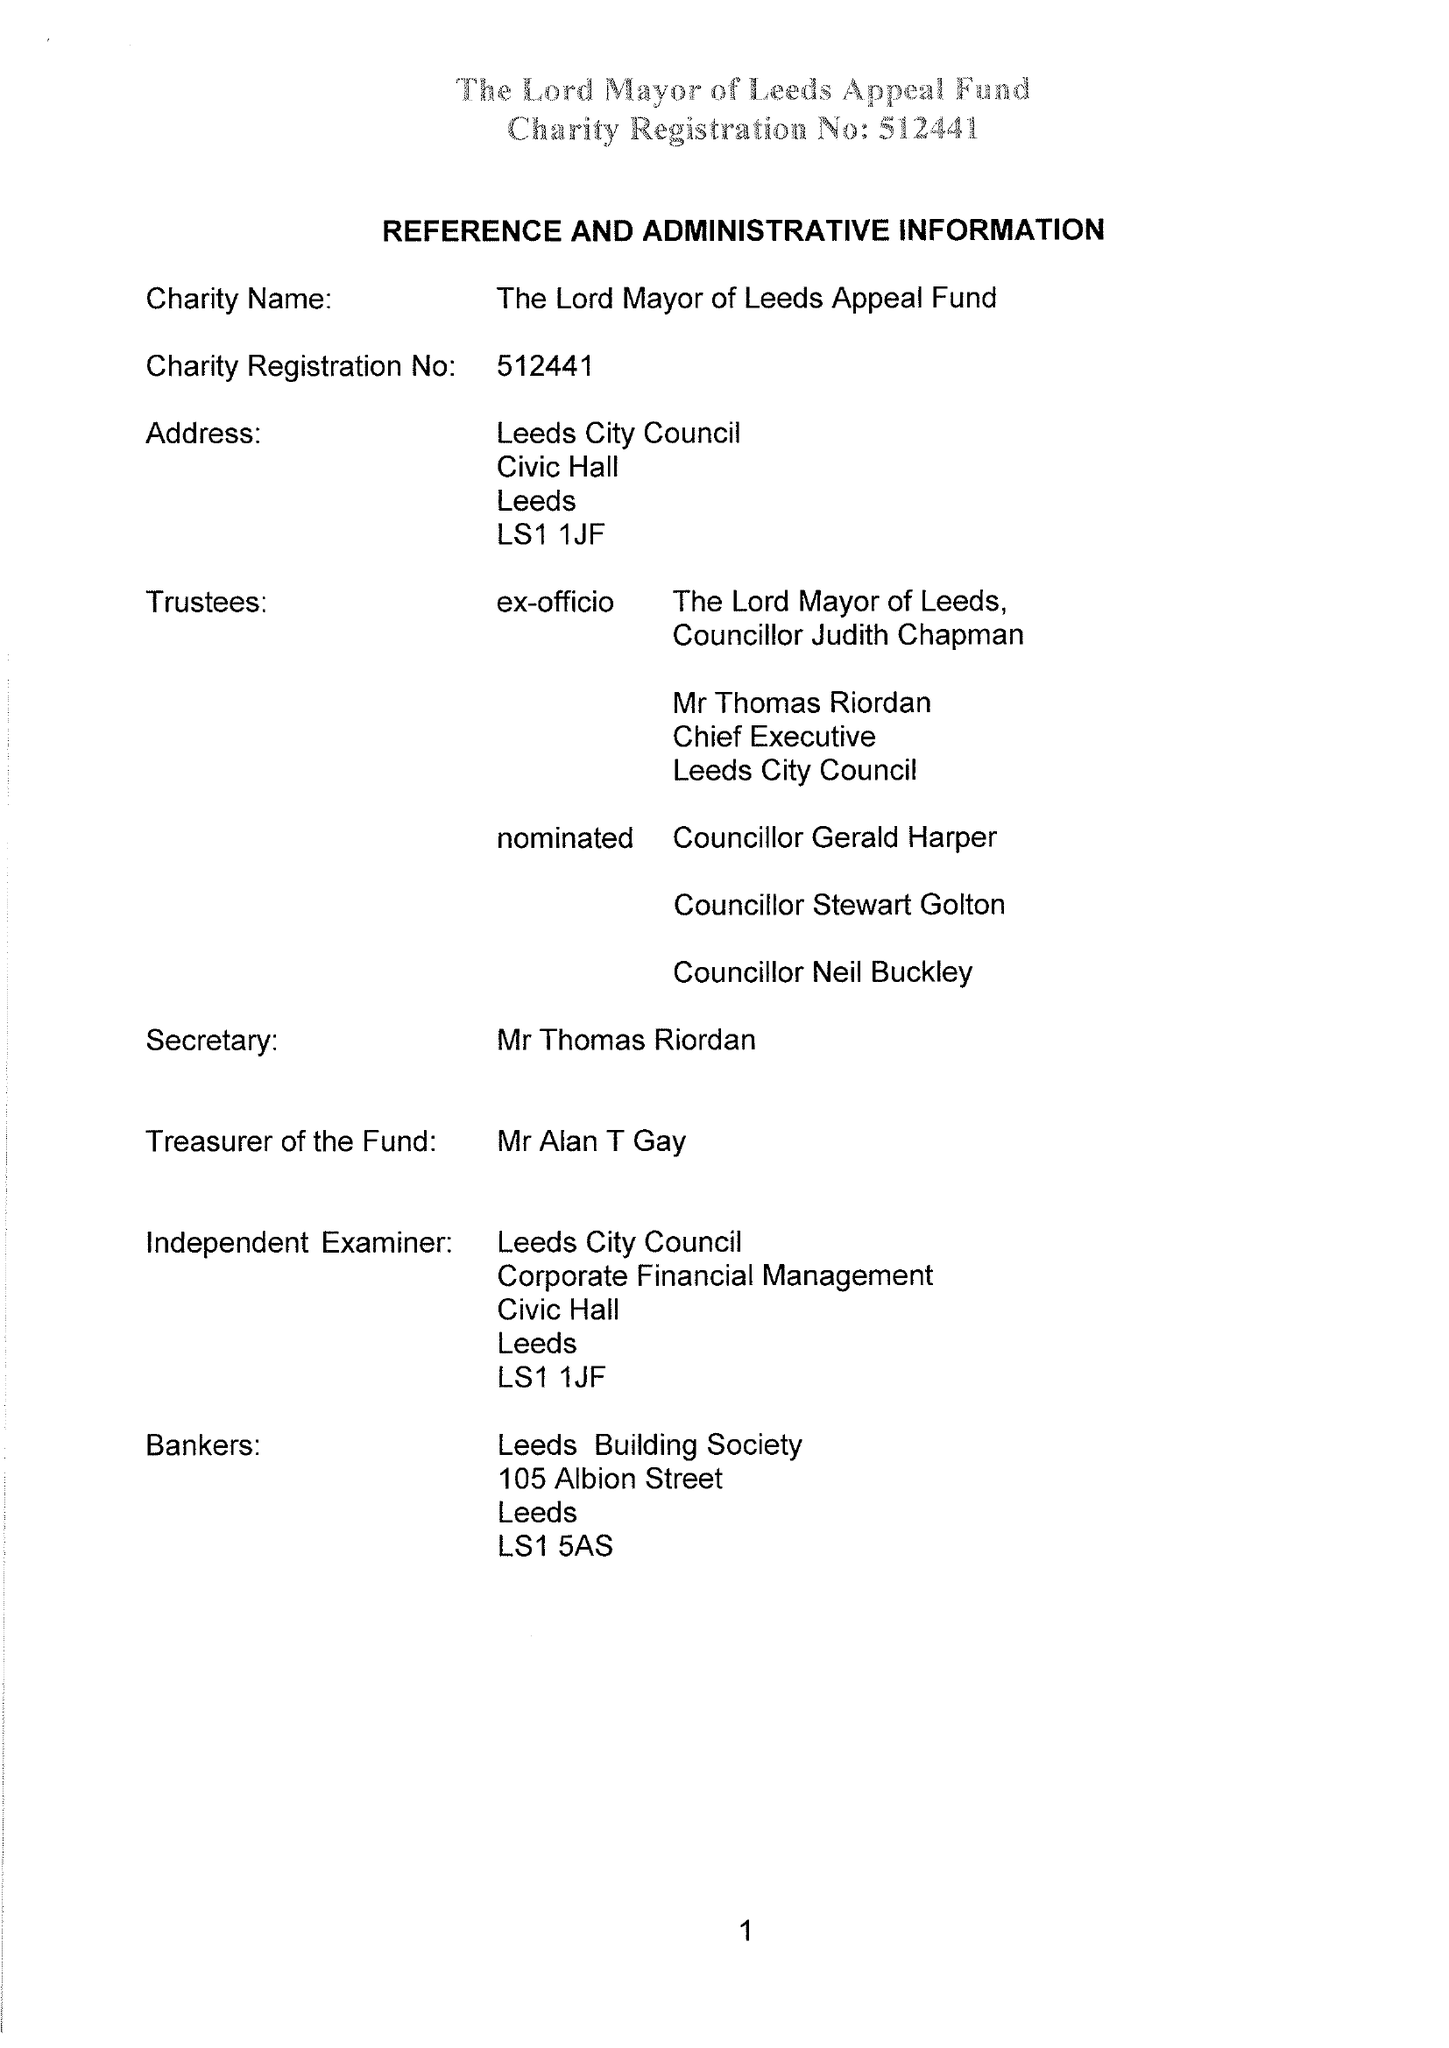What is the value for the report_date?
Answer the question using a single word or phrase. 2016-05-31 